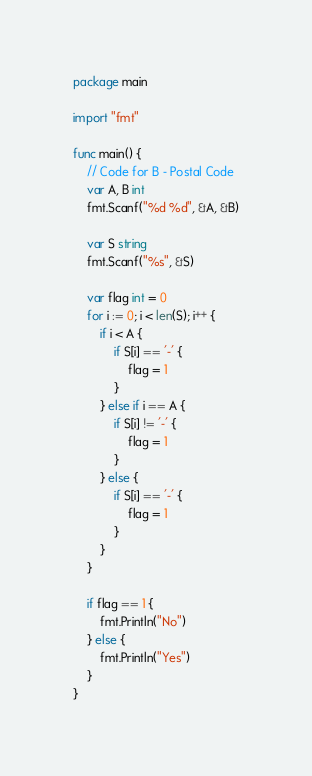Convert code to text. <code><loc_0><loc_0><loc_500><loc_500><_Go_>package main

import "fmt"

func main() {
	// Code for B - Postal Code
	var A, B int
	fmt.Scanf("%d %d", &A, &B)

	var S string
	fmt.Scanf("%s", &S)

	var flag int = 0
	for i := 0; i < len(S); i++ {
		if i < A {
			if S[i] == '-' {
				flag = 1
			}
		} else if i == A {
			if S[i] != '-' {
				flag = 1
			}
		} else {
			if S[i] == '-' {
				flag = 1
			}
		}
	}

	if flag == 1 {
		fmt.Println("No")
	} else {
		fmt.Println("Yes")
	}
}
</code> 